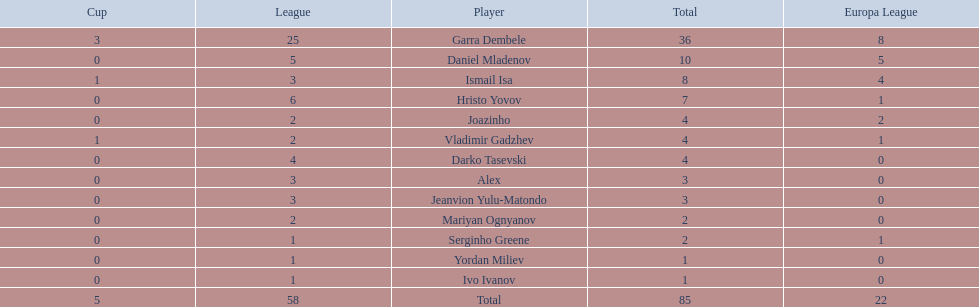What players did not score in all 3 competitions? Daniel Mladenov, Hristo Yovov, Joazinho, Darko Tasevski, Alex, Jeanvion Yulu-Matondo, Mariyan Ognyanov, Serginho Greene, Yordan Miliev, Ivo Ivanov. Which of those did not have total more then 5? Darko Tasevski, Alex, Jeanvion Yulu-Matondo, Mariyan Ognyanov, Serginho Greene, Yordan Miliev, Ivo Ivanov. Which ones scored more then 1 total? Darko Tasevski, Alex, Jeanvion Yulu-Matondo, Mariyan Ognyanov. Which of these player had the lease league points? Mariyan Ognyanov. 